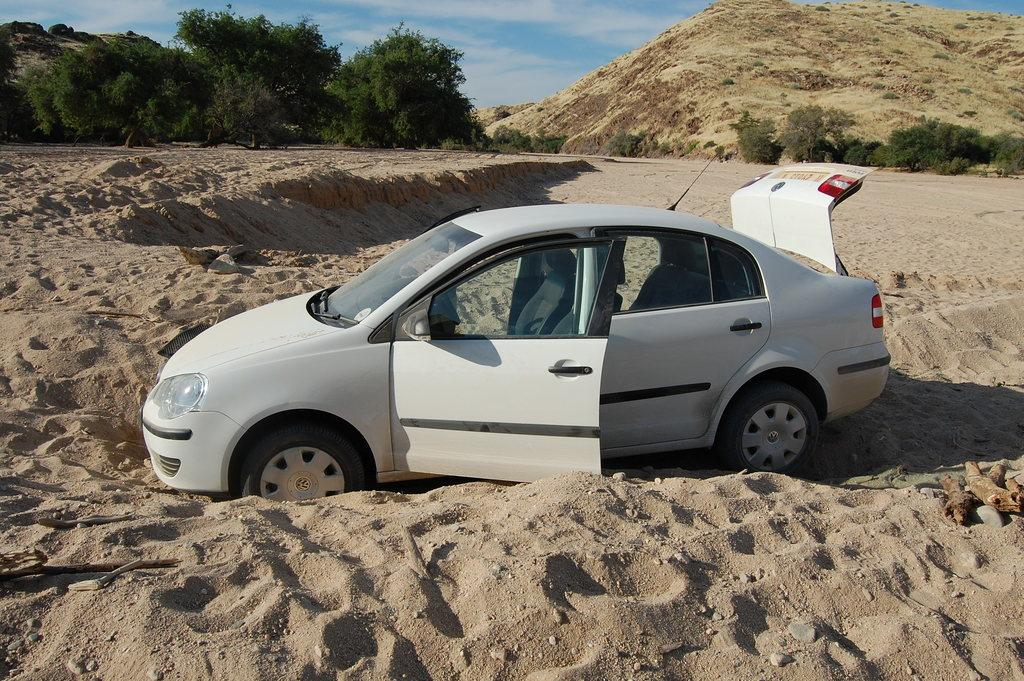What type of vehicle is in the image? There is a white car in the image. What can be seen in the background of the image? Trees and a hill are visible in the image. Which parts of the car are visible in the image? The front doors of the car are visible, and the trunk of the car is opened. How would you describe the sky in the image? The sky is blue and cloudy. Are there any bears sleeping near the car in the image? There is no reference to bears or sleeping in the image, so it is not possible to answer that question. 